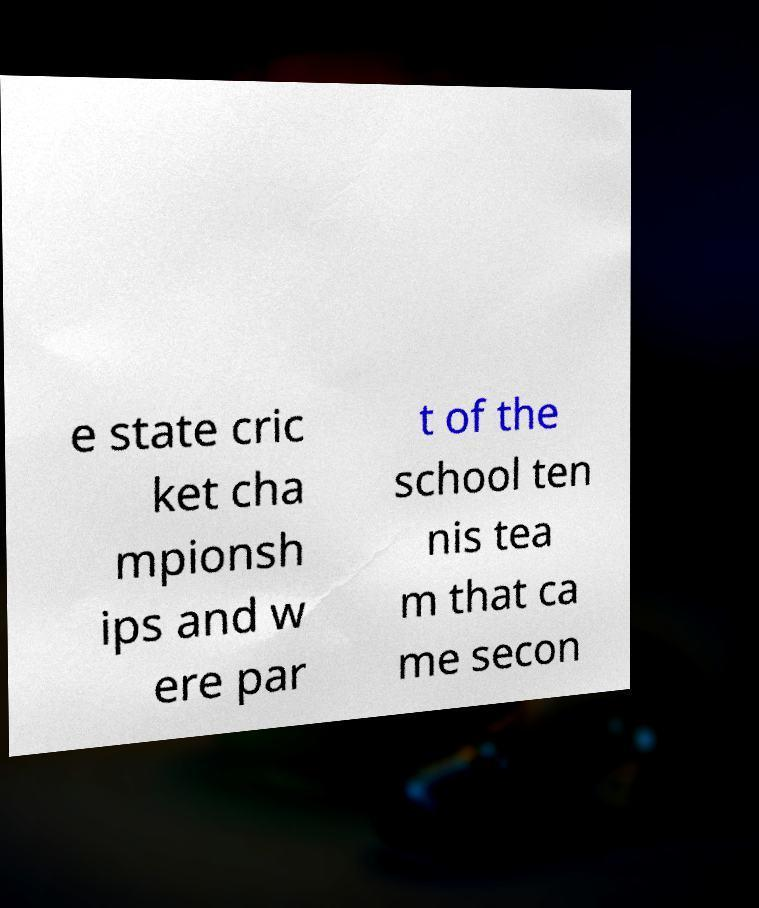Could you extract and type out the text from this image? e state cric ket cha mpionsh ips and w ere par t of the school ten nis tea m that ca me secon 